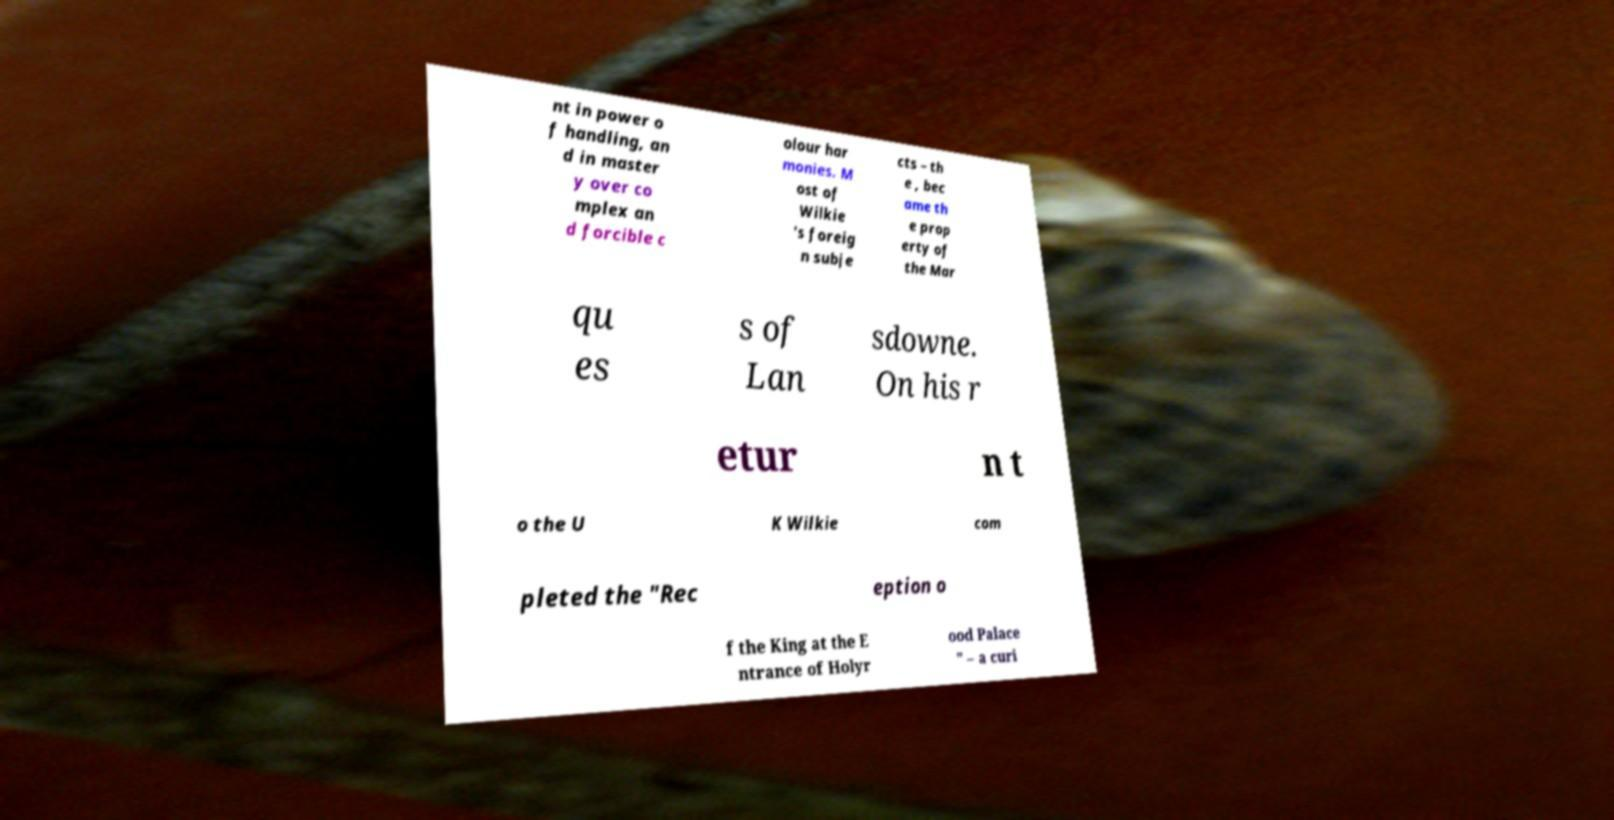Could you assist in decoding the text presented in this image and type it out clearly? nt in power o f handling, an d in master y over co mplex an d forcible c olour har monies. M ost of Wilkie 's foreig n subje cts – th e , bec ame th e prop erty of the Mar qu es s of Lan sdowne. On his r etur n t o the U K Wilkie com pleted the "Rec eption o f the King at the E ntrance of Holyr ood Palace " – a curi 